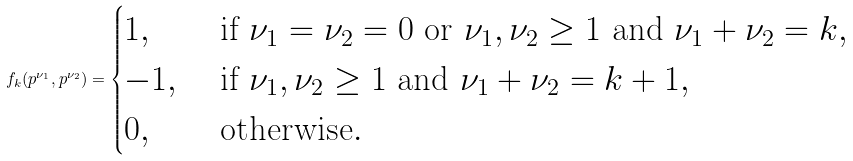Convert formula to latex. <formula><loc_0><loc_0><loc_500><loc_500>f _ { k } ( p ^ { \nu _ { 1 } } , p ^ { \nu _ { 2 } } ) = \begin{cases} 1 , & \text { if $\nu_{1}=\nu_{2}=0$ or $\nu_{1},\nu_{2}\geq 1$ and $\nu_{1}+\nu_{2}=k$} , \\ - 1 , & \text { if $\nu_{1},\nu_{2}\geq 1$ and $\nu_{1}+\nu_{2}=k+1$} , \\ 0 , & \text { otherwise} . \end{cases}</formula> 